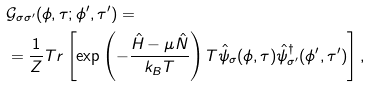<formula> <loc_0><loc_0><loc_500><loc_500>& \mathcal { G } _ { \sigma \sigma ^ { \prime } } ( \phi , \tau ; \phi ^ { \prime } , \tau ^ { \prime } ) = \\ & = \frac { 1 } { Z } T r \left [ \exp \left ( - \frac { \hat { H } - \mu \hat { N } } { k _ { B } T } \right ) T \hat { \psi } _ { \sigma } ( \phi , \tau ) \hat { \psi } _ { \sigma ^ { \prime } } ^ { \dagger } ( \phi ^ { \prime } , \tau ^ { \prime } ) \right ] ,</formula> 